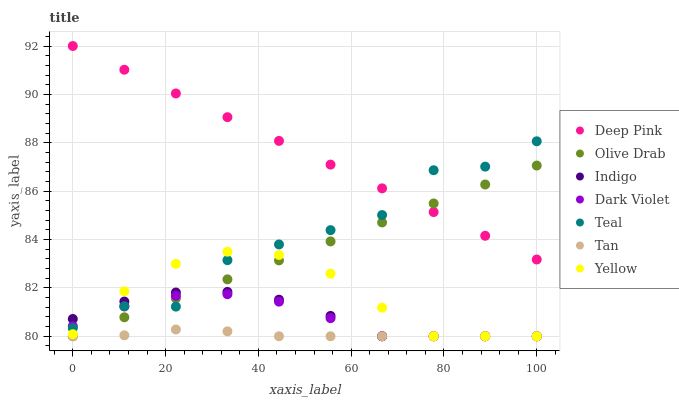Does Tan have the minimum area under the curve?
Answer yes or no. Yes. Does Deep Pink have the maximum area under the curve?
Answer yes or no. Yes. Does Indigo have the minimum area under the curve?
Answer yes or no. No. Does Indigo have the maximum area under the curve?
Answer yes or no. No. Is Deep Pink the smoothest?
Answer yes or no. Yes. Is Teal the roughest?
Answer yes or no. Yes. Is Indigo the smoothest?
Answer yes or no. No. Is Indigo the roughest?
Answer yes or no. No. Does Indigo have the lowest value?
Answer yes or no. Yes. Does Teal have the lowest value?
Answer yes or no. No. Does Deep Pink have the highest value?
Answer yes or no. Yes. Does Indigo have the highest value?
Answer yes or no. No. Is Dark Violet less than Deep Pink?
Answer yes or no. Yes. Is Deep Pink greater than Tan?
Answer yes or no. Yes. Does Dark Violet intersect Yellow?
Answer yes or no. Yes. Is Dark Violet less than Yellow?
Answer yes or no. No. Is Dark Violet greater than Yellow?
Answer yes or no. No. Does Dark Violet intersect Deep Pink?
Answer yes or no. No. 